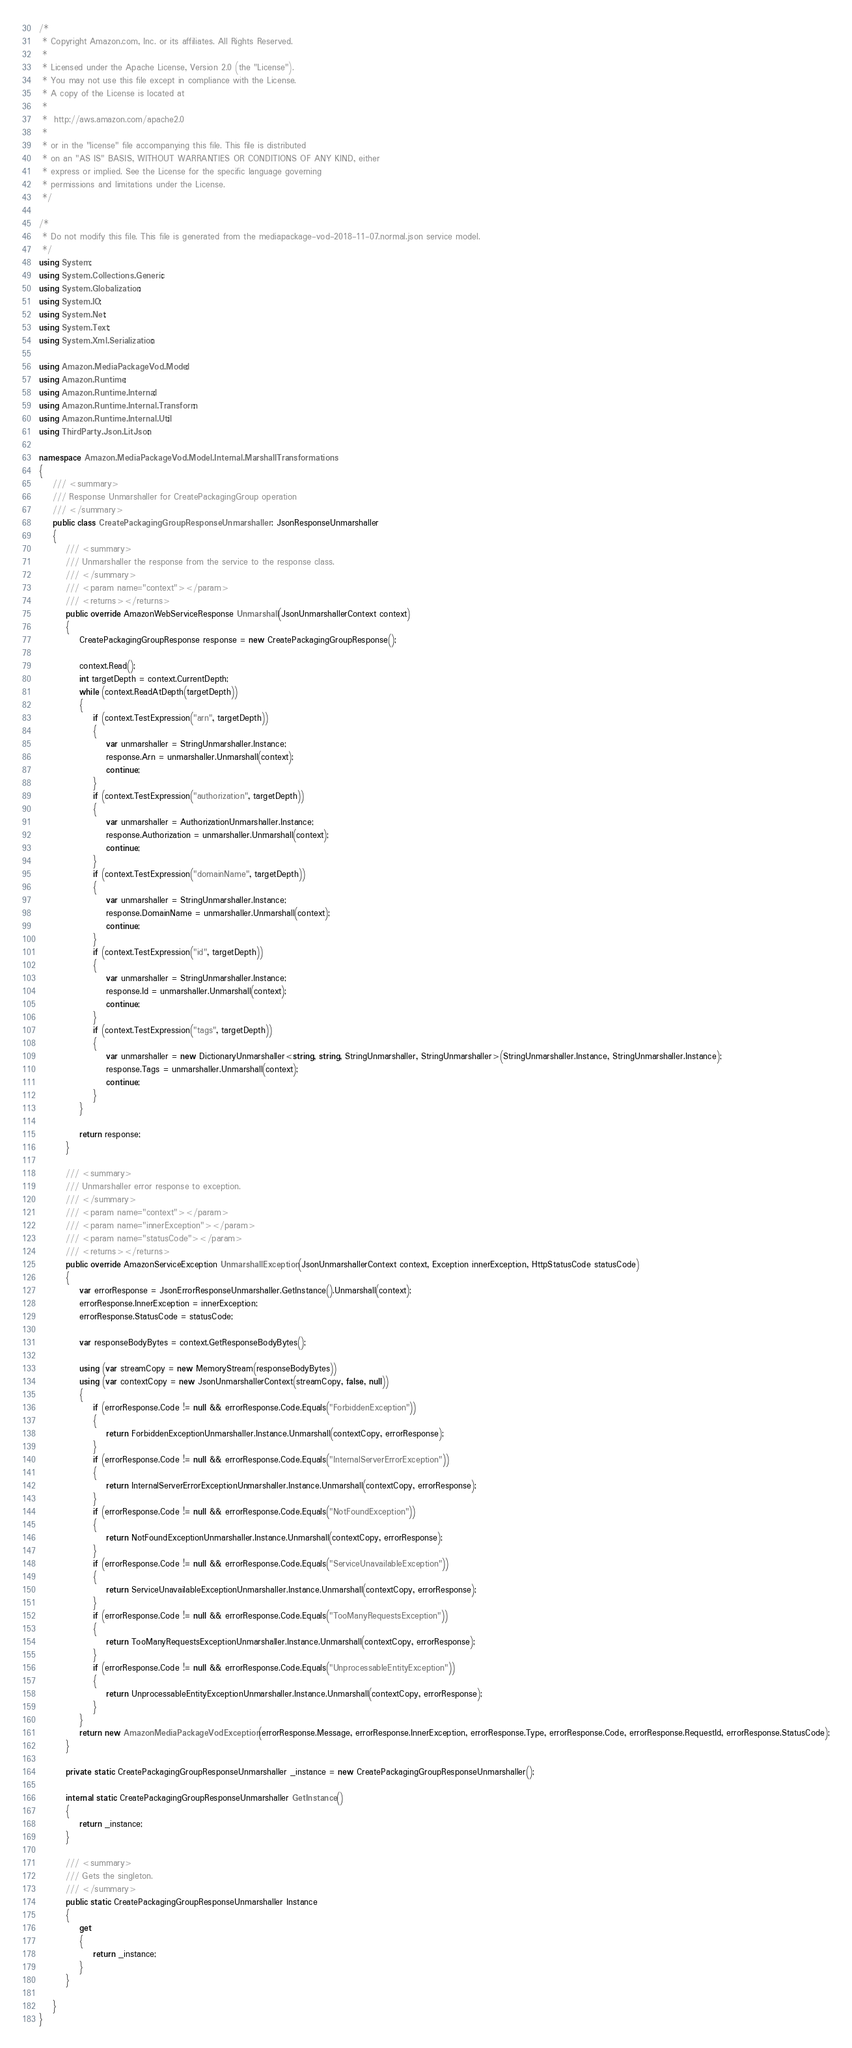Convert code to text. <code><loc_0><loc_0><loc_500><loc_500><_C#_>/*
 * Copyright Amazon.com, Inc. or its affiliates. All Rights Reserved.
 * 
 * Licensed under the Apache License, Version 2.0 (the "License").
 * You may not use this file except in compliance with the License.
 * A copy of the License is located at
 * 
 *  http://aws.amazon.com/apache2.0
 * 
 * or in the "license" file accompanying this file. This file is distributed
 * on an "AS IS" BASIS, WITHOUT WARRANTIES OR CONDITIONS OF ANY KIND, either
 * express or implied. See the License for the specific language governing
 * permissions and limitations under the License.
 */

/*
 * Do not modify this file. This file is generated from the mediapackage-vod-2018-11-07.normal.json service model.
 */
using System;
using System.Collections.Generic;
using System.Globalization;
using System.IO;
using System.Net;
using System.Text;
using System.Xml.Serialization;

using Amazon.MediaPackageVod.Model;
using Amazon.Runtime;
using Amazon.Runtime.Internal;
using Amazon.Runtime.Internal.Transform;
using Amazon.Runtime.Internal.Util;
using ThirdParty.Json.LitJson;

namespace Amazon.MediaPackageVod.Model.Internal.MarshallTransformations
{
    /// <summary>
    /// Response Unmarshaller for CreatePackagingGroup operation
    /// </summary>  
    public class CreatePackagingGroupResponseUnmarshaller : JsonResponseUnmarshaller
    {
        /// <summary>
        /// Unmarshaller the response from the service to the response class.
        /// </summary>  
        /// <param name="context"></param>
        /// <returns></returns>
        public override AmazonWebServiceResponse Unmarshall(JsonUnmarshallerContext context)
        {
            CreatePackagingGroupResponse response = new CreatePackagingGroupResponse();

            context.Read();
            int targetDepth = context.CurrentDepth;
            while (context.ReadAtDepth(targetDepth))
            {
                if (context.TestExpression("arn", targetDepth))
                {
                    var unmarshaller = StringUnmarshaller.Instance;
                    response.Arn = unmarshaller.Unmarshall(context);
                    continue;
                }
                if (context.TestExpression("authorization", targetDepth))
                {
                    var unmarshaller = AuthorizationUnmarshaller.Instance;
                    response.Authorization = unmarshaller.Unmarshall(context);
                    continue;
                }
                if (context.TestExpression("domainName", targetDepth))
                {
                    var unmarshaller = StringUnmarshaller.Instance;
                    response.DomainName = unmarshaller.Unmarshall(context);
                    continue;
                }
                if (context.TestExpression("id", targetDepth))
                {
                    var unmarshaller = StringUnmarshaller.Instance;
                    response.Id = unmarshaller.Unmarshall(context);
                    continue;
                }
                if (context.TestExpression("tags", targetDepth))
                {
                    var unmarshaller = new DictionaryUnmarshaller<string, string, StringUnmarshaller, StringUnmarshaller>(StringUnmarshaller.Instance, StringUnmarshaller.Instance);
                    response.Tags = unmarshaller.Unmarshall(context);
                    continue;
                }
            }

            return response;
        }

        /// <summary>
        /// Unmarshaller error response to exception.
        /// </summary>  
        /// <param name="context"></param>
        /// <param name="innerException"></param>
        /// <param name="statusCode"></param>
        /// <returns></returns>
        public override AmazonServiceException UnmarshallException(JsonUnmarshallerContext context, Exception innerException, HttpStatusCode statusCode)
        {
            var errorResponse = JsonErrorResponseUnmarshaller.GetInstance().Unmarshall(context);
            errorResponse.InnerException = innerException;
            errorResponse.StatusCode = statusCode;

            var responseBodyBytes = context.GetResponseBodyBytes();

            using (var streamCopy = new MemoryStream(responseBodyBytes))
            using (var contextCopy = new JsonUnmarshallerContext(streamCopy, false, null))
            {
                if (errorResponse.Code != null && errorResponse.Code.Equals("ForbiddenException"))
                {
                    return ForbiddenExceptionUnmarshaller.Instance.Unmarshall(contextCopy, errorResponse);
                }
                if (errorResponse.Code != null && errorResponse.Code.Equals("InternalServerErrorException"))
                {
                    return InternalServerErrorExceptionUnmarshaller.Instance.Unmarshall(contextCopy, errorResponse);
                }
                if (errorResponse.Code != null && errorResponse.Code.Equals("NotFoundException"))
                {
                    return NotFoundExceptionUnmarshaller.Instance.Unmarshall(contextCopy, errorResponse);
                }
                if (errorResponse.Code != null && errorResponse.Code.Equals("ServiceUnavailableException"))
                {
                    return ServiceUnavailableExceptionUnmarshaller.Instance.Unmarshall(contextCopy, errorResponse);
                }
                if (errorResponse.Code != null && errorResponse.Code.Equals("TooManyRequestsException"))
                {
                    return TooManyRequestsExceptionUnmarshaller.Instance.Unmarshall(contextCopy, errorResponse);
                }
                if (errorResponse.Code != null && errorResponse.Code.Equals("UnprocessableEntityException"))
                {
                    return UnprocessableEntityExceptionUnmarshaller.Instance.Unmarshall(contextCopy, errorResponse);
                }
            }
            return new AmazonMediaPackageVodException(errorResponse.Message, errorResponse.InnerException, errorResponse.Type, errorResponse.Code, errorResponse.RequestId, errorResponse.StatusCode);
        }

        private static CreatePackagingGroupResponseUnmarshaller _instance = new CreatePackagingGroupResponseUnmarshaller();        

        internal static CreatePackagingGroupResponseUnmarshaller GetInstance()
        {
            return _instance;
        }

        /// <summary>
        /// Gets the singleton.
        /// </summary>  
        public static CreatePackagingGroupResponseUnmarshaller Instance
        {
            get
            {
                return _instance;
            }
        }

    }
}</code> 